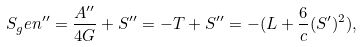<formula> <loc_0><loc_0><loc_500><loc_500>S _ { g } e n ^ { \prime \prime } = \frac { A ^ { \prime \prime } } { 4 G } + S ^ { \prime \prime } = - T + S ^ { \prime \prime } = - ( L + \frac { 6 } { c } ( S ^ { \prime } ) ^ { 2 } ) ,</formula> 